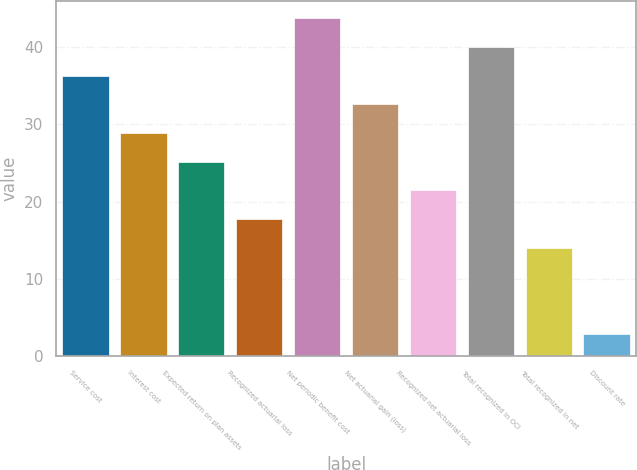Convert chart to OTSL. <chart><loc_0><loc_0><loc_500><loc_500><bar_chart><fcel>Service cost<fcel>Interest cost<fcel>Expected return on plan assets<fcel>Recognized actuarial loss<fcel>Net periodic benefit cost<fcel>Net actuarial gain (loss)<fcel>Recognized net actuarial loss<fcel>Total recognized in OCI<fcel>Total recognized in net<fcel>Discount rate<nl><fcel>36.29<fcel>28.87<fcel>25.16<fcel>17.74<fcel>43.71<fcel>32.58<fcel>21.45<fcel>40<fcel>14.03<fcel>2.9<nl></chart> 